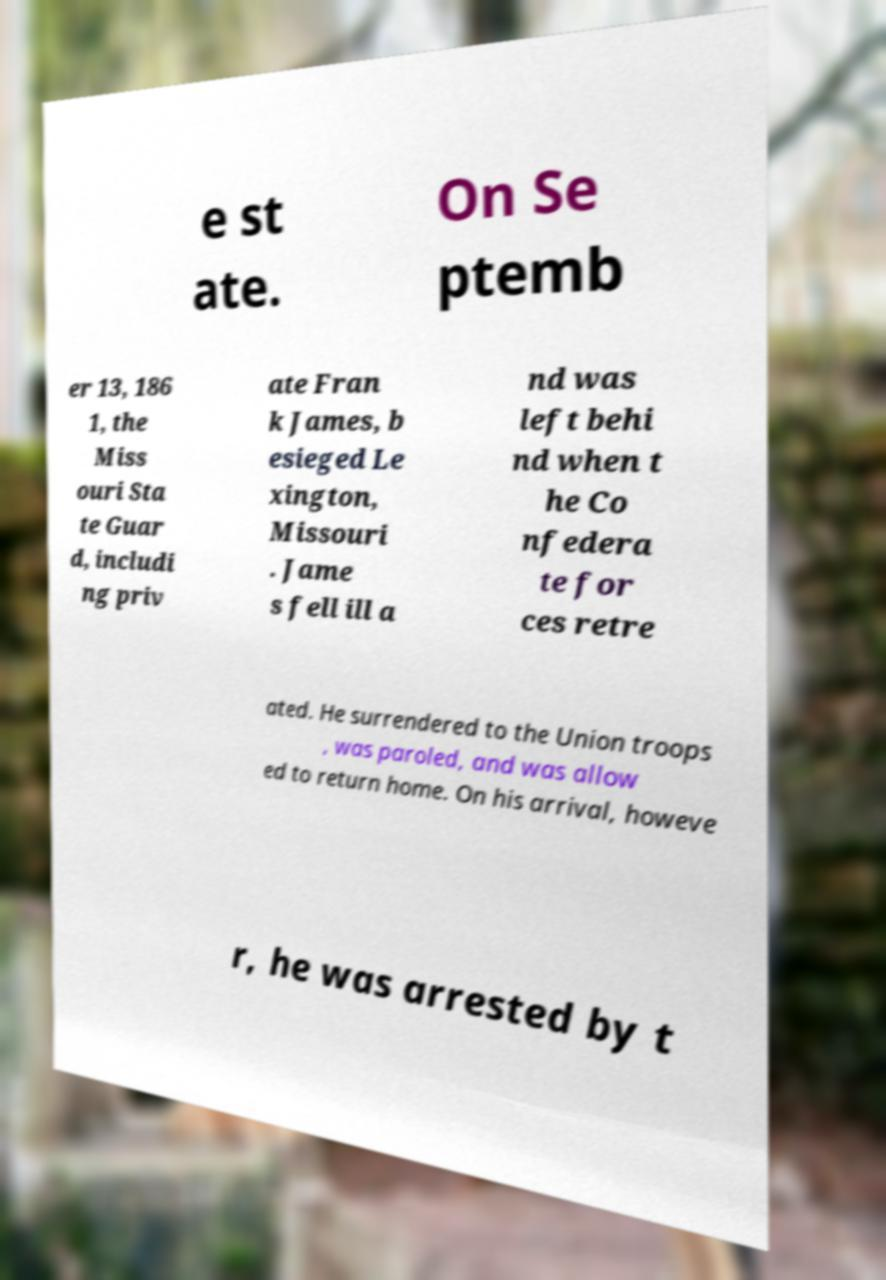Can you read and provide the text displayed in the image?This photo seems to have some interesting text. Can you extract and type it out for me? e st ate. On Se ptemb er 13, 186 1, the Miss ouri Sta te Guar d, includi ng priv ate Fran k James, b esieged Le xington, Missouri . Jame s fell ill a nd was left behi nd when t he Co nfedera te for ces retre ated. He surrendered to the Union troops , was paroled, and was allow ed to return home. On his arrival, howeve r, he was arrested by t 